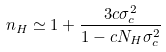<formula> <loc_0><loc_0><loc_500><loc_500>n _ { H } \simeq 1 + \frac { 3 c \sigma _ { c } ^ { 2 } } { 1 - c N _ { H } \sigma _ { c } ^ { 2 } }</formula> 